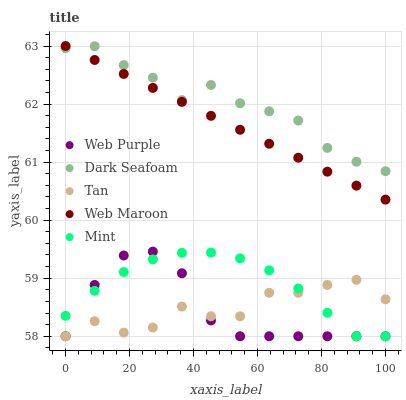Does Web Purple have the minimum area under the curve?
Answer yes or no. Yes. Does Dark Seafoam have the maximum area under the curve?
Answer yes or no. Yes. Does Mint have the minimum area under the curve?
Answer yes or no. No. Does Mint have the maximum area under the curve?
Answer yes or no. No. Is Web Maroon the smoothest?
Answer yes or no. Yes. Is Tan the roughest?
Answer yes or no. Yes. Is Web Purple the smoothest?
Answer yes or no. No. Is Web Purple the roughest?
Answer yes or no. No. Does Web Purple have the lowest value?
Answer yes or no. Yes. Does Dark Seafoam have the lowest value?
Answer yes or no. No. Does Web Maroon have the highest value?
Answer yes or no. Yes. Does Web Purple have the highest value?
Answer yes or no. No. Is Web Purple less than Dark Seafoam?
Answer yes or no. Yes. Is Web Maroon greater than Web Purple?
Answer yes or no. Yes. Does Mint intersect Web Purple?
Answer yes or no. Yes. Is Mint less than Web Purple?
Answer yes or no. No. Is Mint greater than Web Purple?
Answer yes or no. No. Does Web Purple intersect Dark Seafoam?
Answer yes or no. No. 